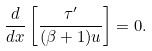<formula> <loc_0><loc_0><loc_500><loc_500>\frac { d } { d x } \left [ \frac { \tau ^ { \prime } } { ( \beta + 1 ) u } \right ] = 0 .</formula> 